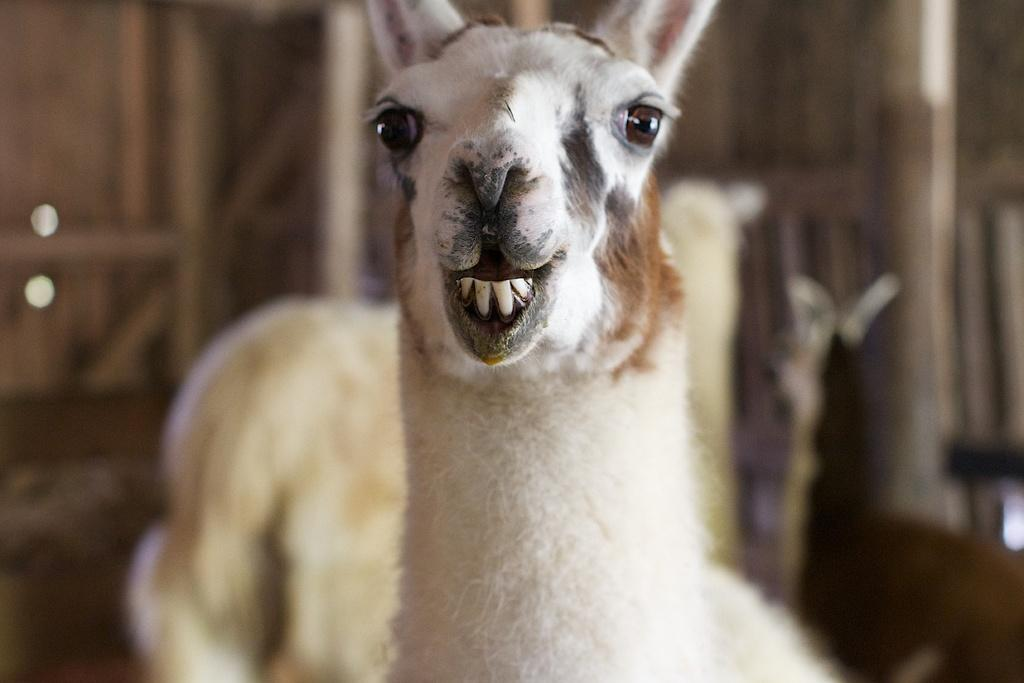What is the main subject in the foreground of the image? There is an animal in the foreground of the image. Can you describe the background of the image? The background of the image is blurry. What reason does the man give for carrying the tray in the image? There is no man or tray present in the image; it only features an animal in the foreground and a blurry background. 